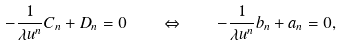Convert formula to latex. <formula><loc_0><loc_0><loc_500><loc_500>- \frac { 1 } { \lambda u ^ { n } } C _ { n } + D _ { n } = 0 \quad \Leftrightarrow \quad - \frac { 1 } { \lambda u ^ { n } } b _ { n } + a _ { n } = 0 ,</formula> 